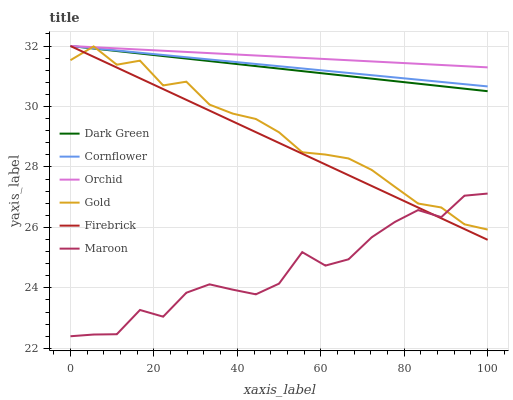Does Maroon have the minimum area under the curve?
Answer yes or no. Yes. Does Orchid have the maximum area under the curve?
Answer yes or no. Yes. Does Gold have the minimum area under the curve?
Answer yes or no. No. Does Gold have the maximum area under the curve?
Answer yes or no. No. Is Cornflower the smoothest?
Answer yes or no. Yes. Is Maroon the roughest?
Answer yes or no. Yes. Is Gold the smoothest?
Answer yes or no. No. Is Gold the roughest?
Answer yes or no. No. Does Maroon have the lowest value?
Answer yes or no. Yes. Does Gold have the lowest value?
Answer yes or no. No. Does Orchid have the highest value?
Answer yes or no. Yes. Does Gold have the highest value?
Answer yes or no. No. Is Maroon less than Cornflower?
Answer yes or no. Yes. Is Orchid greater than Maroon?
Answer yes or no. Yes. Does Maroon intersect Firebrick?
Answer yes or no. Yes. Is Maroon less than Firebrick?
Answer yes or no. No. Is Maroon greater than Firebrick?
Answer yes or no. No. Does Maroon intersect Cornflower?
Answer yes or no. No. 